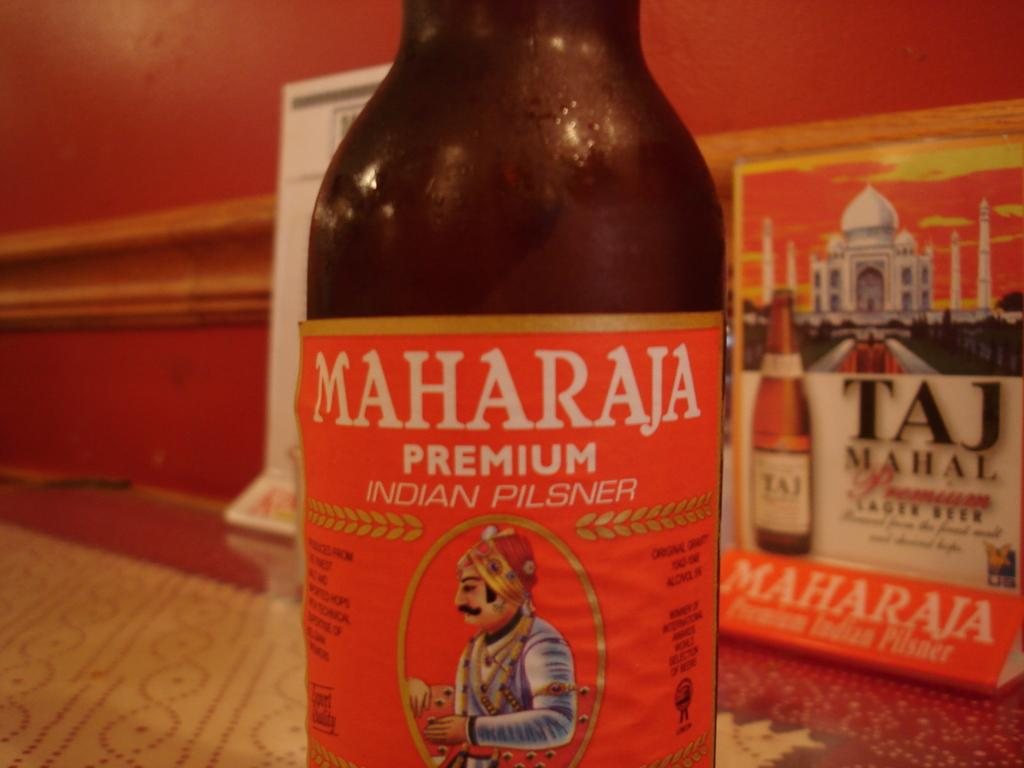<image>
Present a compact description of the photo's key features. A bottle of MaharaJa Premium Indian Pilsner sits on a table. 